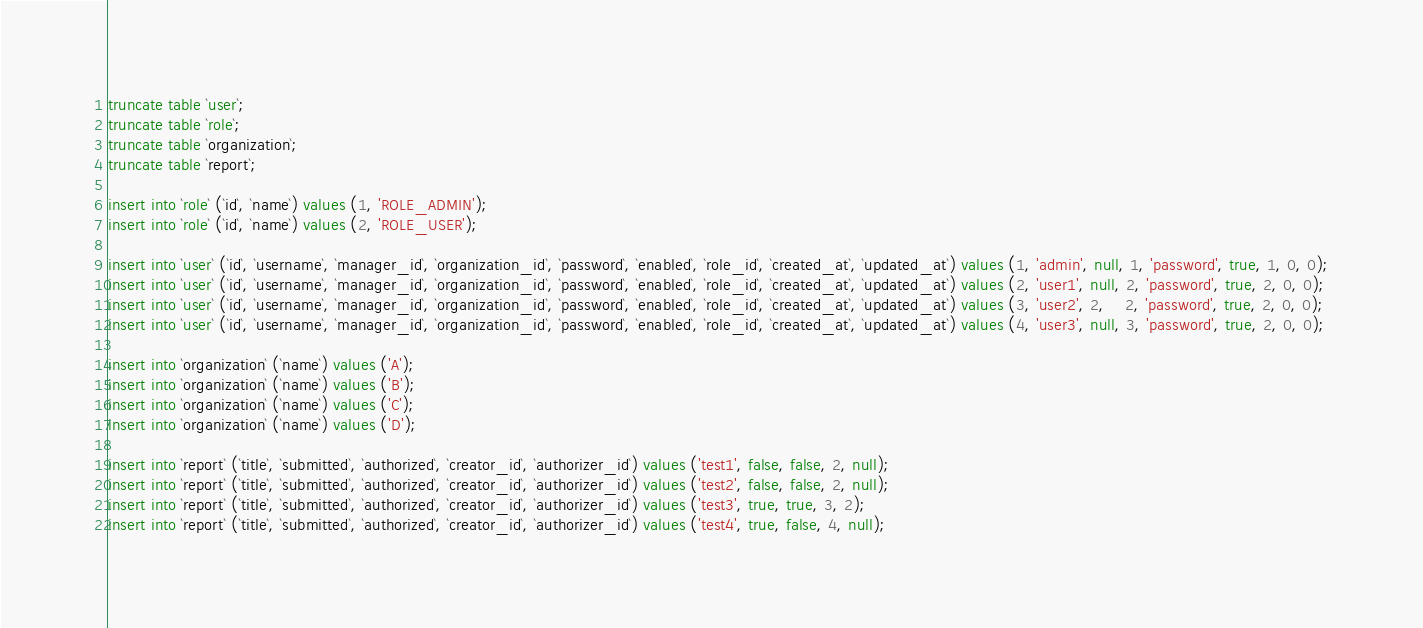<code> <loc_0><loc_0><loc_500><loc_500><_SQL_>truncate table `user`;
truncate table `role`;
truncate table `organization`;
truncate table `report`;

insert into `role` (`id`, `name`) values (1, 'ROLE_ADMIN');
insert into `role` (`id`, `name`) values (2, 'ROLE_USER');

insert into `user` (`id`, `username`, `manager_id`, `organization_id`, `password`, `enabled`, `role_id`, `created_at`, `updated_at`) values (1, 'admin', null, 1, 'password', true, 1, 0, 0);
insert into `user` (`id`, `username`, `manager_id`, `organization_id`, `password`, `enabled`, `role_id`, `created_at`, `updated_at`) values (2, 'user1', null, 2, 'password', true, 2, 0, 0);
insert into `user` (`id`, `username`, `manager_id`, `organization_id`, `password`, `enabled`, `role_id`, `created_at`, `updated_at`) values (3, 'user2', 2,    2, 'password', true, 2, 0, 0);
insert into `user` (`id`, `username`, `manager_id`, `organization_id`, `password`, `enabled`, `role_id`, `created_at`, `updated_at`) values (4, 'user3', null, 3, 'password', true, 2, 0, 0);

insert into `organization` (`name`) values ('A');
insert into `organization` (`name`) values ('B');
insert into `organization` (`name`) values ('C');
insert into `organization` (`name`) values ('D');

insert into `report` (`title`, `submitted`, `authorized`, `creator_id`, `authorizer_id`) values ('test1', false, false, 2, null);
insert into `report` (`title`, `submitted`, `authorized`, `creator_id`, `authorizer_id`) values ('test2', false, false, 2, null);
insert into `report` (`title`, `submitted`, `authorized`, `creator_id`, `authorizer_id`) values ('test3', true, true, 3, 2);
insert into `report` (`title`, `submitted`, `authorized`, `creator_id`, `authorizer_id`) values ('test4', true, false, 4, null);
</code> 